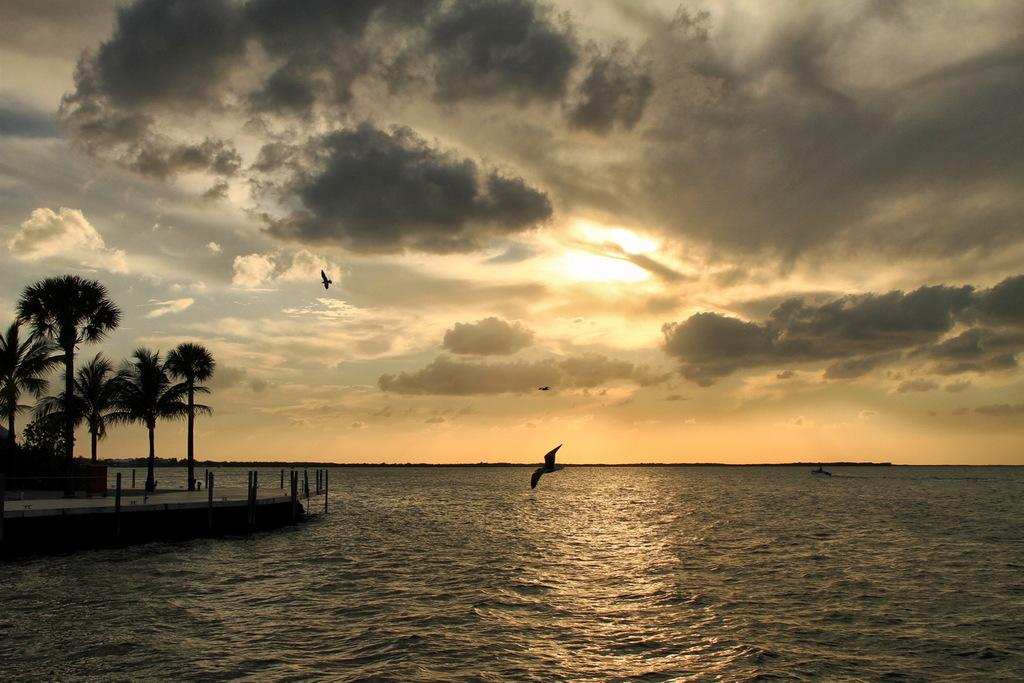What is at the bottom of the image? There is water at the bottom of the image. What can be seen flying in the air in the image? There are birds in the air. What type of vegetation is on the left side of the image? There are trees on the left side of the image. What is visible at the top of the image? The sky is visible at the top of the image. What can be seen in the sky in the image? Clouds are present in the sky. What flavor of table is visible in the image? There is no table present in the image, and therefore no flavor can be associated with it. How does the water roll in the image? The water does not roll in the image; it is stationary at the bottom. 